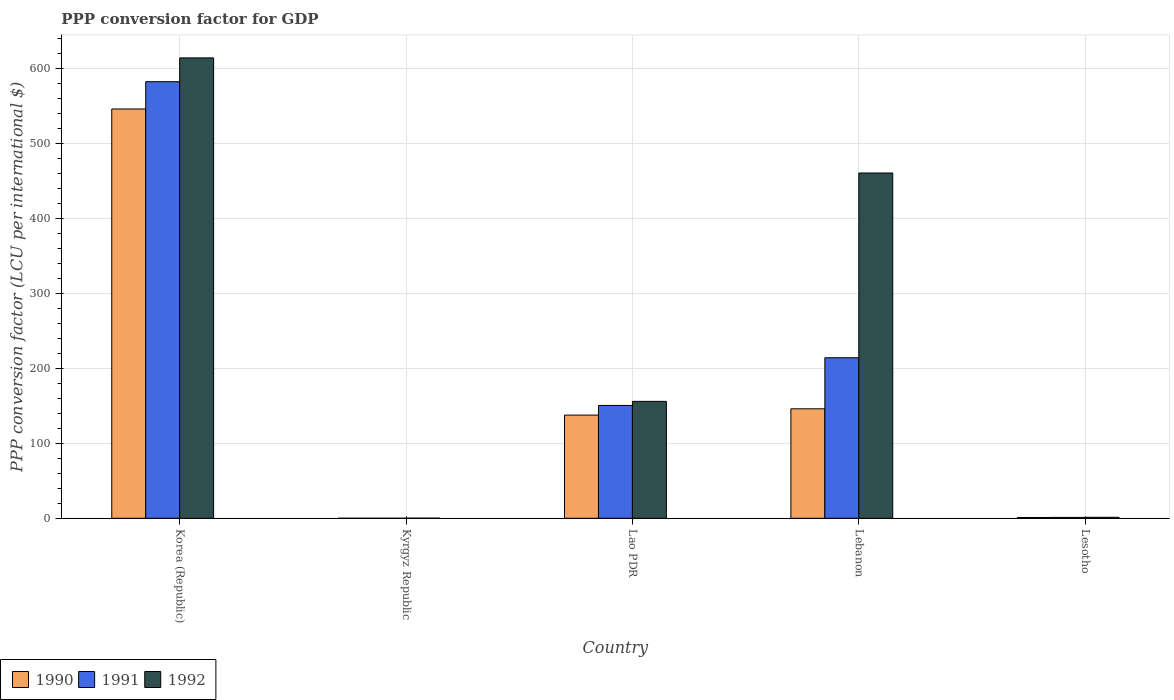Are the number of bars per tick equal to the number of legend labels?
Offer a terse response. Yes. Are the number of bars on each tick of the X-axis equal?
Offer a terse response. Yes. What is the label of the 2nd group of bars from the left?
Your answer should be compact. Kyrgyz Republic. In how many cases, is the number of bars for a given country not equal to the number of legend labels?
Make the answer very short. 0. What is the PPP conversion factor for GDP in 1991 in Lesotho?
Your response must be concise. 1.17. Across all countries, what is the maximum PPP conversion factor for GDP in 1992?
Keep it short and to the point. 614.12. Across all countries, what is the minimum PPP conversion factor for GDP in 1990?
Keep it short and to the point. 0. In which country was the PPP conversion factor for GDP in 1990 minimum?
Make the answer very short. Kyrgyz Republic. What is the total PPP conversion factor for GDP in 1990 in the graph?
Offer a terse response. 830.69. What is the difference between the PPP conversion factor for GDP in 1991 in Korea (Republic) and that in Lesotho?
Provide a succinct answer. 581.22. What is the difference between the PPP conversion factor for GDP in 1992 in Lebanon and the PPP conversion factor for GDP in 1990 in Kyrgyz Republic?
Keep it short and to the point. 460.58. What is the average PPP conversion factor for GDP in 1990 per country?
Your response must be concise. 166.14. What is the difference between the PPP conversion factor for GDP of/in 1992 and PPP conversion factor for GDP of/in 1990 in Lebanon?
Your answer should be compact. 314.57. In how many countries, is the PPP conversion factor for GDP in 1991 greater than 100 LCU?
Give a very brief answer. 3. What is the ratio of the PPP conversion factor for GDP in 1990 in Lao PDR to that in Lesotho?
Ensure brevity in your answer.  131.18. Is the PPP conversion factor for GDP in 1990 in Kyrgyz Republic less than that in Lao PDR?
Provide a succinct answer. Yes. What is the difference between the highest and the second highest PPP conversion factor for GDP in 1992?
Your answer should be very brief. -304.64. What is the difference between the highest and the lowest PPP conversion factor for GDP in 1990?
Your response must be concise. 545.98. In how many countries, is the PPP conversion factor for GDP in 1990 greater than the average PPP conversion factor for GDP in 1990 taken over all countries?
Provide a short and direct response. 1. Is the sum of the PPP conversion factor for GDP in 1991 in Kyrgyz Republic and Lesotho greater than the maximum PPP conversion factor for GDP in 1990 across all countries?
Provide a succinct answer. No. What does the 2nd bar from the left in Lao PDR represents?
Provide a short and direct response. 1991. Is it the case that in every country, the sum of the PPP conversion factor for GDP in 1992 and PPP conversion factor for GDP in 1990 is greater than the PPP conversion factor for GDP in 1991?
Provide a short and direct response. Yes. Are the values on the major ticks of Y-axis written in scientific E-notation?
Make the answer very short. No. Does the graph contain any zero values?
Offer a terse response. No. Does the graph contain grids?
Give a very brief answer. Yes. Where does the legend appear in the graph?
Ensure brevity in your answer.  Bottom left. How many legend labels are there?
Your answer should be very brief. 3. How are the legend labels stacked?
Ensure brevity in your answer.  Horizontal. What is the title of the graph?
Make the answer very short. PPP conversion factor for GDP. Does "1986" appear as one of the legend labels in the graph?
Make the answer very short. No. What is the label or title of the Y-axis?
Make the answer very short. PPP conversion factor (LCU per international $). What is the PPP conversion factor (LCU per international $) in 1990 in Korea (Republic)?
Your answer should be very brief. 545.98. What is the PPP conversion factor (LCU per international $) of 1991 in Korea (Republic)?
Ensure brevity in your answer.  582.39. What is the PPP conversion factor (LCU per international $) of 1992 in Korea (Republic)?
Give a very brief answer. 614.12. What is the PPP conversion factor (LCU per international $) of 1990 in Kyrgyz Republic?
Offer a very short reply. 0. What is the PPP conversion factor (LCU per international $) of 1991 in Kyrgyz Republic?
Your answer should be compact. 0.01. What is the PPP conversion factor (LCU per international $) of 1992 in Kyrgyz Republic?
Keep it short and to the point. 0.09. What is the PPP conversion factor (LCU per international $) of 1990 in Lao PDR?
Make the answer very short. 137.64. What is the PPP conversion factor (LCU per international $) in 1991 in Lao PDR?
Your answer should be very brief. 150.48. What is the PPP conversion factor (LCU per international $) of 1992 in Lao PDR?
Your response must be concise. 155.95. What is the PPP conversion factor (LCU per international $) in 1990 in Lebanon?
Your answer should be compact. 146.02. What is the PPP conversion factor (LCU per international $) of 1991 in Lebanon?
Your answer should be compact. 214.14. What is the PPP conversion factor (LCU per international $) of 1992 in Lebanon?
Ensure brevity in your answer.  460.59. What is the PPP conversion factor (LCU per international $) of 1990 in Lesotho?
Provide a succinct answer. 1.05. What is the PPP conversion factor (LCU per international $) of 1991 in Lesotho?
Give a very brief answer. 1.17. What is the PPP conversion factor (LCU per international $) of 1992 in Lesotho?
Provide a succinct answer. 1.3. Across all countries, what is the maximum PPP conversion factor (LCU per international $) of 1990?
Keep it short and to the point. 545.98. Across all countries, what is the maximum PPP conversion factor (LCU per international $) in 1991?
Make the answer very short. 582.39. Across all countries, what is the maximum PPP conversion factor (LCU per international $) of 1992?
Your answer should be compact. 614.12. Across all countries, what is the minimum PPP conversion factor (LCU per international $) of 1990?
Ensure brevity in your answer.  0. Across all countries, what is the minimum PPP conversion factor (LCU per international $) in 1991?
Your answer should be very brief. 0.01. Across all countries, what is the minimum PPP conversion factor (LCU per international $) in 1992?
Offer a terse response. 0.09. What is the total PPP conversion factor (LCU per international $) in 1990 in the graph?
Keep it short and to the point. 830.69. What is the total PPP conversion factor (LCU per international $) of 1991 in the graph?
Ensure brevity in your answer.  948.19. What is the total PPP conversion factor (LCU per international $) of 1992 in the graph?
Ensure brevity in your answer.  1232.05. What is the difference between the PPP conversion factor (LCU per international $) in 1990 in Korea (Republic) and that in Kyrgyz Republic?
Provide a succinct answer. 545.98. What is the difference between the PPP conversion factor (LCU per international $) in 1991 in Korea (Republic) and that in Kyrgyz Republic?
Keep it short and to the point. 582.38. What is the difference between the PPP conversion factor (LCU per international $) in 1992 in Korea (Republic) and that in Kyrgyz Republic?
Offer a very short reply. 614.04. What is the difference between the PPP conversion factor (LCU per international $) of 1990 in Korea (Republic) and that in Lao PDR?
Offer a terse response. 408.34. What is the difference between the PPP conversion factor (LCU per international $) in 1991 in Korea (Republic) and that in Lao PDR?
Offer a terse response. 431.9. What is the difference between the PPP conversion factor (LCU per international $) in 1992 in Korea (Republic) and that in Lao PDR?
Your answer should be compact. 458.18. What is the difference between the PPP conversion factor (LCU per international $) of 1990 in Korea (Republic) and that in Lebanon?
Provide a short and direct response. 399.96. What is the difference between the PPP conversion factor (LCU per international $) of 1991 in Korea (Republic) and that in Lebanon?
Offer a terse response. 368.25. What is the difference between the PPP conversion factor (LCU per international $) in 1992 in Korea (Republic) and that in Lebanon?
Provide a succinct answer. 153.54. What is the difference between the PPP conversion factor (LCU per international $) of 1990 in Korea (Republic) and that in Lesotho?
Provide a short and direct response. 544.93. What is the difference between the PPP conversion factor (LCU per international $) in 1991 in Korea (Republic) and that in Lesotho?
Give a very brief answer. 581.22. What is the difference between the PPP conversion factor (LCU per international $) in 1992 in Korea (Republic) and that in Lesotho?
Your answer should be compact. 612.83. What is the difference between the PPP conversion factor (LCU per international $) in 1990 in Kyrgyz Republic and that in Lao PDR?
Make the answer very short. -137.63. What is the difference between the PPP conversion factor (LCU per international $) in 1991 in Kyrgyz Republic and that in Lao PDR?
Offer a very short reply. -150.47. What is the difference between the PPP conversion factor (LCU per international $) in 1992 in Kyrgyz Republic and that in Lao PDR?
Give a very brief answer. -155.86. What is the difference between the PPP conversion factor (LCU per international $) in 1990 in Kyrgyz Republic and that in Lebanon?
Provide a succinct answer. -146.01. What is the difference between the PPP conversion factor (LCU per international $) in 1991 in Kyrgyz Republic and that in Lebanon?
Provide a short and direct response. -214.13. What is the difference between the PPP conversion factor (LCU per international $) of 1992 in Kyrgyz Republic and that in Lebanon?
Your answer should be very brief. -460.5. What is the difference between the PPP conversion factor (LCU per international $) in 1990 in Kyrgyz Republic and that in Lesotho?
Offer a terse response. -1.04. What is the difference between the PPP conversion factor (LCU per international $) of 1991 in Kyrgyz Republic and that in Lesotho?
Keep it short and to the point. -1.16. What is the difference between the PPP conversion factor (LCU per international $) in 1992 in Kyrgyz Republic and that in Lesotho?
Give a very brief answer. -1.21. What is the difference between the PPP conversion factor (LCU per international $) of 1990 in Lao PDR and that in Lebanon?
Offer a very short reply. -8.38. What is the difference between the PPP conversion factor (LCU per international $) in 1991 in Lao PDR and that in Lebanon?
Provide a succinct answer. -63.66. What is the difference between the PPP conversion factor (LCU per international $) of 1992 in Lao PDR and that in Lebanon?
Keep it short and to the point. -304.64. What is the difference between the PPP conversion factor (LCU per international $) of 1990 in Lao PDR and that in Lesotho?
Your response must be concise. 136.59. What is the difference between the PPP conversion factor (LCU per international $) of 1991 in Lao PDR and that in Lesotho?
Ensure brevity in your answer.  149.32. What is the difference between the PPP conversion factor (LCU per international $) of 1992 in Lao PDR and that in Lesotho?
Provide a succinct answer. 154.65. What is the difference between the PPP conversion factor (LCU per international $) of 1990 in Lebanon and that in Lesotho?
Provide a short and direct response. 144.97. What is the difference between the PPP conversion factor (LCU per international $) in 1991 in Lebanon and that in Lesotho?
Provide a short and direct response. 212.98. What is the difference between the PPP conversion factor (LCU per international $) of 1992 in Lebanon and that in Lesotho?
Your answer should be compact. 459.29. What is the difference between the PPP conversion factor (LCU per international $) in 1990 in Korea (Republic) and the PPP conversion factor (LCU per international $) in 1991 in Kyrgyz Republic?
Give a very brief answer. 545.97. What is the difference between the PPP conversion factor (LCU per international $) in 1990 in Korea (Republic) and the PPP conversion factor (LCU per international $) in 1992 in Kyrgyz Republic?
Keep it short and to the point. 545.89. What is the difference between the PPP conversion factor (LCU per international $) in 1991 in Korea (Republic) and the PPP conversion factor (LCU per international $) in 1992 in Kyrgyz Republic?
Make the answer very short. 582.3. What is the difference between the PPP conversion factor (LCU per international $) in 1990 in Korea (Republic) and the PPP conversion factor (LCU per international $) in 1991 in Lao PDR?
Offer a very short reply. 395.5. What is the difference between the PPP conversion factor (LCU per international $) of 1990 in Korea (Republic) and the PPP conversion factor (LCU per international $) of 1992 in Lao PDR?
Provide a short and direct response. 390.03. What is the difference between the PPP conversion factor (LCU per international $) in 1991 in Korea (Republic) and the PPP conversion factor (LCU per international $) in 1992 in Lao PDR?
Your answer should be very brief. 426.44. What is the difference between the PPP conversion factor (LCU per international $) of 1990 in Korea (Republic) and the PPP conversion factor (LCU per international $) of 1991 in Lebanon?
Keep it short and to the point. 331.84. What is the difference between the PPP conversion factor (LCU per international $) in 1990 in Korea (Republic) and the PPP conversion factor (LCU per international $) in 1992 in Lebanon?
Offer a terse response. 85.39. What is the difference between the PPP conversion factor (LCU per international $) in 1991 in Korea (Republic) and the PPP conversion factor (LCU per international $) in 1992 in Lebanon?
Ensure brevity in your answer.  121.8. What is the difference between the PPP conversion factor (LCU per international $) of 1990 in Korea (Republic) and the PPP conversion factor (LCU per international $) of 1991 in Lesotho?
Your response must be concise. 544.81. What is the difference between the PPP conversion factor (LCU per international $) in 1990 in Korea (Republic) and the PPP conversion factor (LCU per international $) in 1992 in Lesotho?
Your answer should be compact. 544.68. What is the difference between the PPP conversion factor (LCU per international $) of 1991 in Korea (Republic) and the PPP conversion factor (LCU per international $) of 1992 in Lesotho?
Make the answer very short. 581.09. What is the difference between the PPP conversion factor (LCU per international $) in 1990 in Kyrgyz Republic and the PPP conversion factor (LCU per international $) in 1991 in Lao PDR?
Provide a succinct answer. -150.48. What is the difference between the PPP conversion factor (LCU per international $) of 1990 in Kyrgyz Republic and the PPP conversion factor (LCU per international $) of 1992 in Lao PDR?
Your answer should be compact. -155.94. What is the difference between the PPP conversion factor (LCU per international $) of 1991 in Kyrgyz Republic and the PPP conversion factor (LCU per international $) of 1992 in Lao PDR?
Your answer should be compact. -155.94. What is the difference between the PPP conversion factor (LCU per international $) of 1990 in Kyrgyz Republic and the PPP conversion factor (LCU per international $) of 1991 in Lebanon?
Give a very brief answer. -214.14. What is the difference between the PPP conversion factor (LCU per international $) in 1990 in Kyrgyz Republic and the PPP conversion factor (LCU per international $) in 1992 in Lebanon?
Offer a terse response. -460.58. What is the difference between the PPP conversion factor (LCU per international $) of 1991 in Kyrgyz Republic and the PPP conversion factor (LCU per international $) of 1992 in Lebanon?
Your answer should be compact. -460.58. What is the difference between the PPP conversion factor (LCU per international $) of 1990 in Kyrgyz Republic and the PPP conversion factor (LCU per international $) of 1991 in Lesotho?
Your response must be concise. -1.16. What is the difference between the PPP conversion factor (LCU per international $) of 1990 in Kyrgyz Republic and the PPP conversion factor (LCU per international $) of 1992 in Lesotho?
Provide a succinct answer. -1.29. What is the difference between the PPP conversion factor (LCU per international $) in 1991 in Kyrgyz Republic and the PPP conversion factor (LCU per international $) in 1992 in Lesotho?
Give a very brief answer. -1.29. What is the difference between the PPP conversion factor (LCU per international $) of 1990 in Lao PDR and the PPP conversion factor (LCU per international $) of 1991 in Lebanon?
Your response must be concise. -76.5. What is the difference between the PPP conversion factor (LCU per international $) of 1990 in Lao PDR and the PPP conversion factor (LCU per international $) of 1992 in Lebanon?
Make the answer very short. -322.95. What is the difference between the PPP conversion factor (LCU per international $) of 1991 in Lao PDR and the PPP conversion factor (LCU per international $) of 1992 in Lebanon?
Offer a very short reply. -310.1. What is the difference between the PPP conversion factor (LCU per international $) of 1990 in Lao PDR and the PPP conversion factor (LCU per international $) of 1991 in Lesotho?
Your answer should be very brief. 136.47. What is the difference between the PPP conversion factor (LCU per international $) in 1990 in Lao PDR and the PPP conversion factor (LCU per international $) in 1992 in Lesotho?
Provide a succinct answer. 136.34. What is the difference between the PPP conversion factor (LCU per international $) in 1991 in Lao PDR and the PPP conversion factor (LCU per international $) in 1992 in Lesotho?
Keep it short and to the point. 149.19. What is the difference between the PPP conversion factor (LCU per international $) in 1990 in Lebanon and the PPP conversion factor (LCU per international $) in 1991 in Lesotho?
Ensure brevity in your answer.  144.85. What is the difference between the PPP conversion factor (LCU per international $) in 1990 in Lebanon and the PPP conversion factor (LCU per international $) in 1992 in Lesotho?
Keep it short and to the point. 144.72. What is the difference between the PPP conversion factor (LCU per international $) in 1991 in Lebanon and the PPP conversion factor (LCU per international $) in 1992 in Lesotho?
Ensure brevity in your answer.  212.84. What is the average PPP conversion factor (LCU per international $) in 1990 per country?
Your answer should be compact. 166.14. What is the average PPP conversion factor (LCU per international $) in 1991 per country?
Provide a short and direct response. 189.64. What is the average PPP conversion factor (LCU per international $) of 1992 per country?
Provide a succinct answer. 246.41. What is the difference between the PPP conversion factor (LCU per international $) of 1990 and PPP conversion factor (LCU per international $) of 1991 in Korea (Republic)?
Ensure brevity in your answer.  -36.41. What is the difference between the PPP conversion factor (LCU per international $) of 1990 and PPP conversion factor (LCU per international $) of 1992 in Korea (Republic)?
Your response must be concise. -68.14. What is the difference between the PPP conversion factor (LCU per international $) of 1991 and PPP conversion factor (LCU per international $) of 1992 in Korea (Republic)?
Your answer should be compact. -31.74. What is the difference between the PPP conversion factor (LCU per international $) in 1990 and PPP conversion factor (LCU per international $) in 1991 in Kyrgyz Republic?
Offer a very short reply. -0.01. What is the difference between the PPP conversion factor (LCU per international $) in 1990 and PPP conversion factor (LCU per international $) in 1992 in Kyrgyz Republic?
Your answer should be very brief. -0.09. What is the difference between the PPP conversion factor (LCU per international $) of 1991 and PPP conversion factor (LCU per international $) of 1992 in Kyrgyz Republic?
Give a very brief answer. -0.08. What is the difference between the PPP conversion factor (LCU per international $) of 1990 and PPP conversion factor (LCU per international $) of 1991 in Lao PDR?
Offer a terse response. -12.85. What is the difference between the PPP conversion factor (LCU per international $) in 1990 and PPP conversion factor (LCU per international $) in 1992 in Lao PDR?
Provide a succinct answer. -18.31. What is the difference between the PPP conversion factor (LCU per international $) in 1991 and PPP conversion factor (LCU per international $) in 1992 in Lao PDR?
Your answer should be very brief. -5.46. What is the difference between the PPP conversion factor (LCU per international $) in 1990 and PPP conversion factor (LCU per international $) in 1991 in Lebanon?
Your answer should be very brief. -68.13. What is the difference between the PPP conversion factor (LCU per international $) in 1990 and PPP conversion factor (LCU per international $) in 1992 in Lebanon?
Ensure brevity in your answer.  -314.57. What is the difference between the PPP conversion factor (LCU per international $) in 1991 and PPP conversion factor (LCU per international $) in 1992 in Lebanon?
Offer a very short reply. -246.45. What is the difference between the PPP conversion factor (LCU per international $) of 1990 and PPP conversion factor (LCU per international $) of 1991 in Lesotho?
Offer a terse response. -0.12. What is the difference between the PPP conversion factor (LCU per international $) of 1990 and PPP conversion factor (LCU per international $) of 1992 in Lesotho?
Provide a short and direct response. -0.25. What is the difference between the PPP conversion factor (LCU per international $) in 1991 and PPP conversion factor (LCU per international $) in 1992 in Lesotho?
Offer a terse response. -0.13. What is the ratio of the PPP conversion factor (LCU per international $) of 1990 in Korea (Republic) to that in Kyrgyz Republic?
Keep it short and to the point. 1.26e+05. What is the ratio of the PPP conversion factor (LCU per international $) of 1991 in Korea (Republic) to that in Kyrgyz Republic?
Your answer should be very brief. 5.91e+04. What is the ratio of the PPP conversion factor (LCU per international $) of 1992 in Korea (Republic) to that in Kyrgyz Republic?
Your answer should be compact. 6851.33. What is the ratio of the PPP conversion factor (LCU per international $) in 1990 in Korea (Republic) to that in Lao PDR?
Provide a succinct answer. 3.97. What is the ratio of the PPP conversion factor (LCU per international $) in 1991 in Korea (Republic) to that in Lao PDR?
Your answer should be compact. 3.87. What is the ratio of the PPP conversion factor (LCU per international $) in 1992 in Korea (Republic) to that in Lao PDR?
Offer a terse response. 3.94. What is the ratio of the PPP conversion factor (LCU per international $) of 1990 in Korea (Republic) to that in Lebanon?
Offer a very short reply. 3.74. What is the ratio of the PPP conversion factor (LCU per international $) of 1991 in Korea (Republic) to that in Lebanon?
Your response must be concise. 2.72. What is the ratio of the PPP conversion factor (LCU per international $) in 1992 in Korea (Republic) to that in Lebanon?
Your answer should be compact. 1.33. What is the ratio of the PPP conversion factor (LCU per international $) in 1990 in Korea (Republic) to that in Lesotho?
Offer a very short reply. 520.35. What is the ratio of the PPP conversion factor (LCU per international $) of 1991 in Korea (Republic) to that in Lesotho?
Keep it short and to the point. 499.49. What is the ratio of the PPP conversion factor (LCU per international $) in 1992 in Korea (Republic) to that in Lesotho?
Your answer should be very brief. 472.65. What is the ratio of the PPP conversion factor (LCU per international $) in 1991 in Kyrgyz Republic to that in Lao PDR?
Provide a succinct answer. 0. What is the ratio of the PPP conversion factor (LCU per international $) of 1992 in Kyrgyz Republic to that in Lao PDR?
Offer a very short reply. 0. What is the ratio of the PPP conversion factor (LCU per international $) of 1991 in Kyrgyz Republic to that in Lebanon?
Give a very brief answer. 0. What is the ratio of the PPP conversion factor (LCU per international $) of 1990 in Kyrgyz Republic to that in Lesotho?
Keep it short and to the point. 0. What is the ratio of the PPP conversion factor (LCU per international $) of 1991 in Kyrgyz Republic to that in Lesotho?
Offer a terse response. 0.01. What is the ratio of the PPP conversion factor (LCU per international $) of 1992 in Kyrgyz Republic to that in Lesotho?
Offer a terse response. 0.07. What is the ratio of the PPP conversion factor (LCU per international $) of 1990 in Lao PDR to that in Lebanon?
Keep it short and to the point. 0.94. What is the ratio of the PPP conversion factor (LCU per international $) of 1991 in Lao PDR to that in Lebanon?
Give a very brief answer. 0.7. What is the ratio of the PPP conversion factor (LCU per international $) of 1992 in Lao PDR to that in Lebanon?
Offer a terse response. 0.34. What is the ratio of the PPP conversion factor (LCU per international $) in 1990 in Lao PDR to that in Lesotho?
Make the answer very short. 131.18. What is the ratio of the PPP conversion factor (LCU per international $) of 1991 in Lao PDR to that in Lesotho?
Your response must be concise. 129.07. What is the ratio of the PPP conversion factor (LCU per international $) in 1992 in Lao PDR to that in Lesotho?
Offer a terse response. 120.02. What is the ratio of the PPP conversion factor (LCU per international $) in 1990 in Lebanon to that in Lesotho?
Your response must be concise. 139.16. What is the ratio of the PPP conversion factor (LCU per international $) in 1991 in Lebanon to that in Lesotho?
Provide a succinct answer. 183.66. What is the ratio of the PPP conversion factor (LCU per international $) of 1992 in Lebanon to that in Lesotho?
Offer a terse response. 354.48. What is the difference between the highest and the second highest PPP conversion factor (LCU per international $) in 1990?
Offer a terse response. 399.96. What is the difference between the highest and the second highest PPP conversion factor (LCU per international $) of 1991?
Offer a very short reply. 368.25. What is the difference between the highest and the second highest PPP conversion factor (LCU per international $) of 1992?
Your response must be concise. 153.54. What is the difference between the highest and the lowest PPP conversion factor (LCU per international $) in 1990?
Offer a very short reply. 545.98. What is the difference between the highest and the lowest PPP conversion factor (LCU per international $) in 1991?
Keep it short and to the point. 582.38. What is the difference between the highest and the lowest PPP conversion factor (LCU per international $) of 1992?
Ensure brevity in your answer.  614.04. 